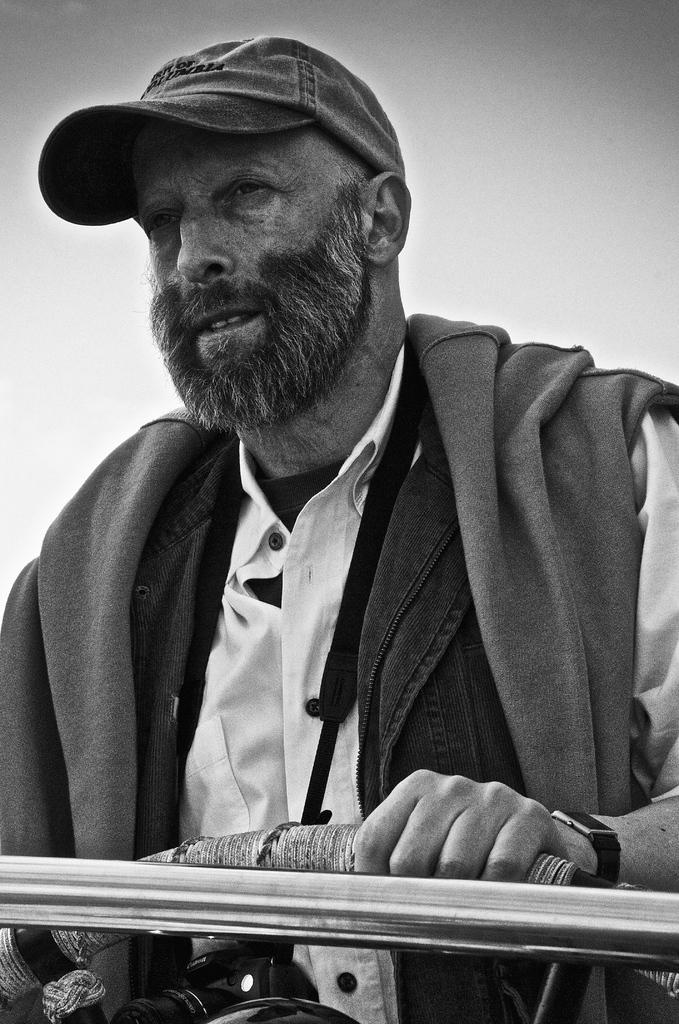What is the color scheme of the image? The image is black and white. Who is present in the image? There is a man in the image. What is the man wearing on his head? The man is wearing a cap. What is the man holding in the image? The man is holding an object. What can be seen in the background of the image? The sky is visible in the background of the image. Can you tell me how many stamps are on the man's shirt in the image? There are no stamps visible on the man's shirt in the image, as it is black and white and does not show any stamps. 